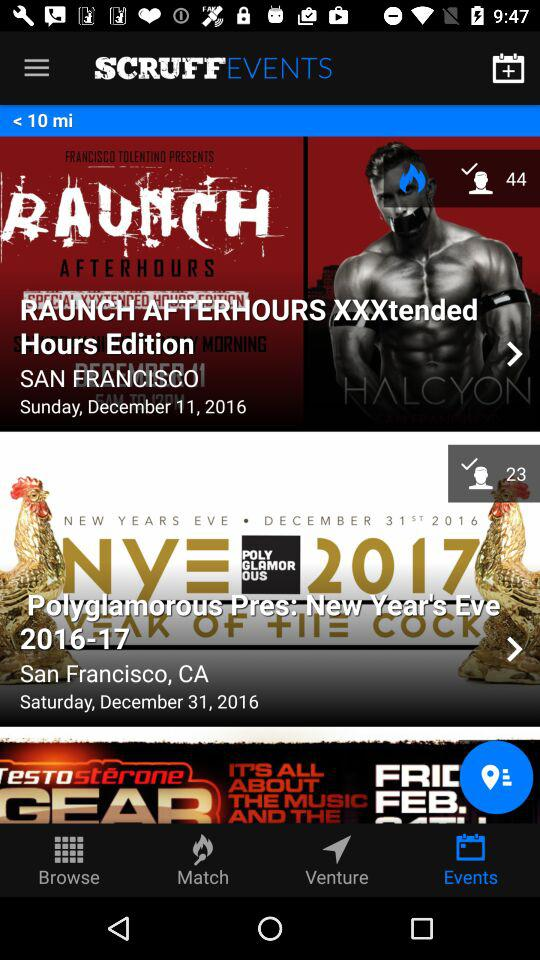What is the number of people interested in the event "Polyglamorous Pres"? The number of people interested in the event "Polyglamorous Pres" is 23. 